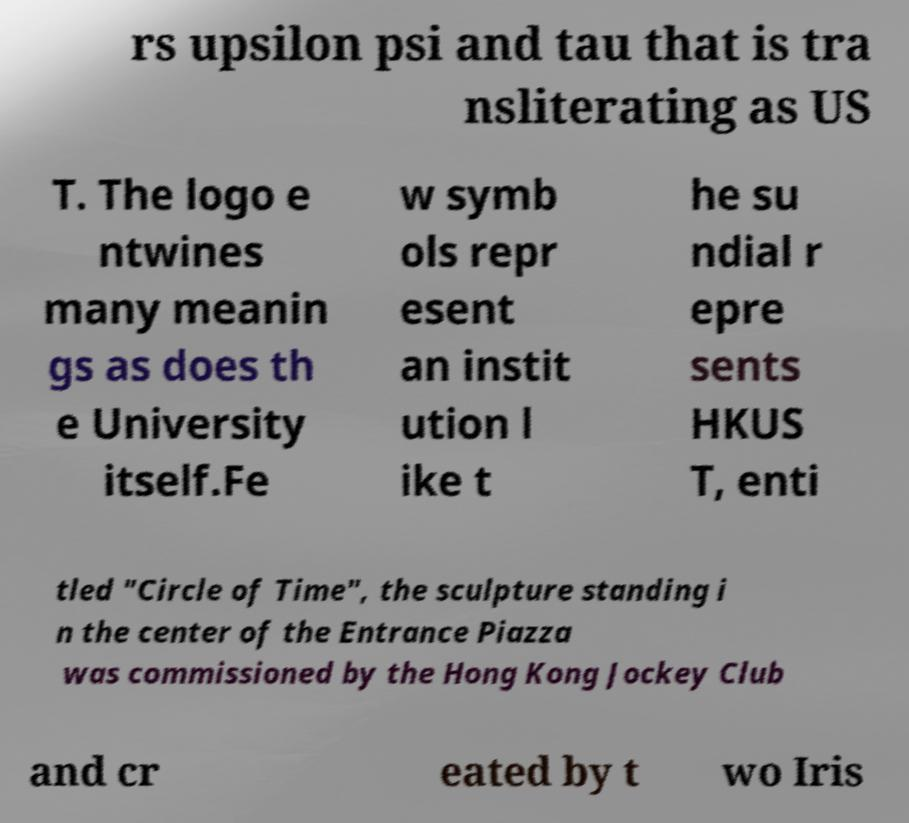I need the written content from this picture converted into text. Can you do that? rs upsilon psi and tau that is tra nsliterating as US T. The logo e ntwines many meanin gs as does th e University itself.Fe w symb ols repr esent an instit ution l ike t he su ndial r epre sents HKUS T, enti tled "Circle of Time", the sculpture standing i n the center of the Entrance Piazza was commissioned by the Hong Kong Jockey Club and cr eated by t wo Iris 